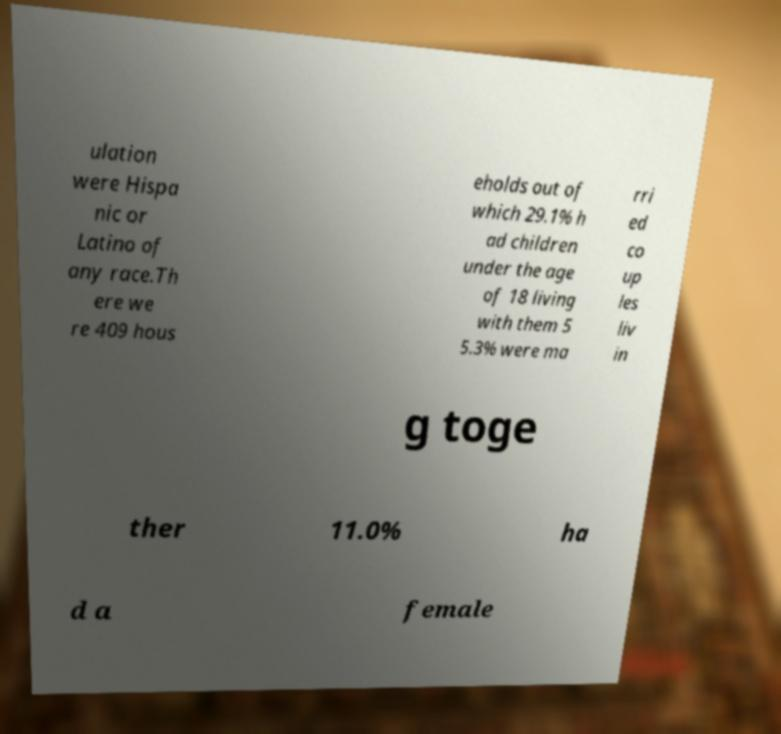Please read and relay the text visible in this image. What does it say? ulation were Hispa nic or Latino of any race.Th ere we re 409 hous eholds out of which 29.1% h ad children under the age of 18 living with them 5 5.3% were ma rri ed co up les liv in g toge ther 11.0% ha d a female 